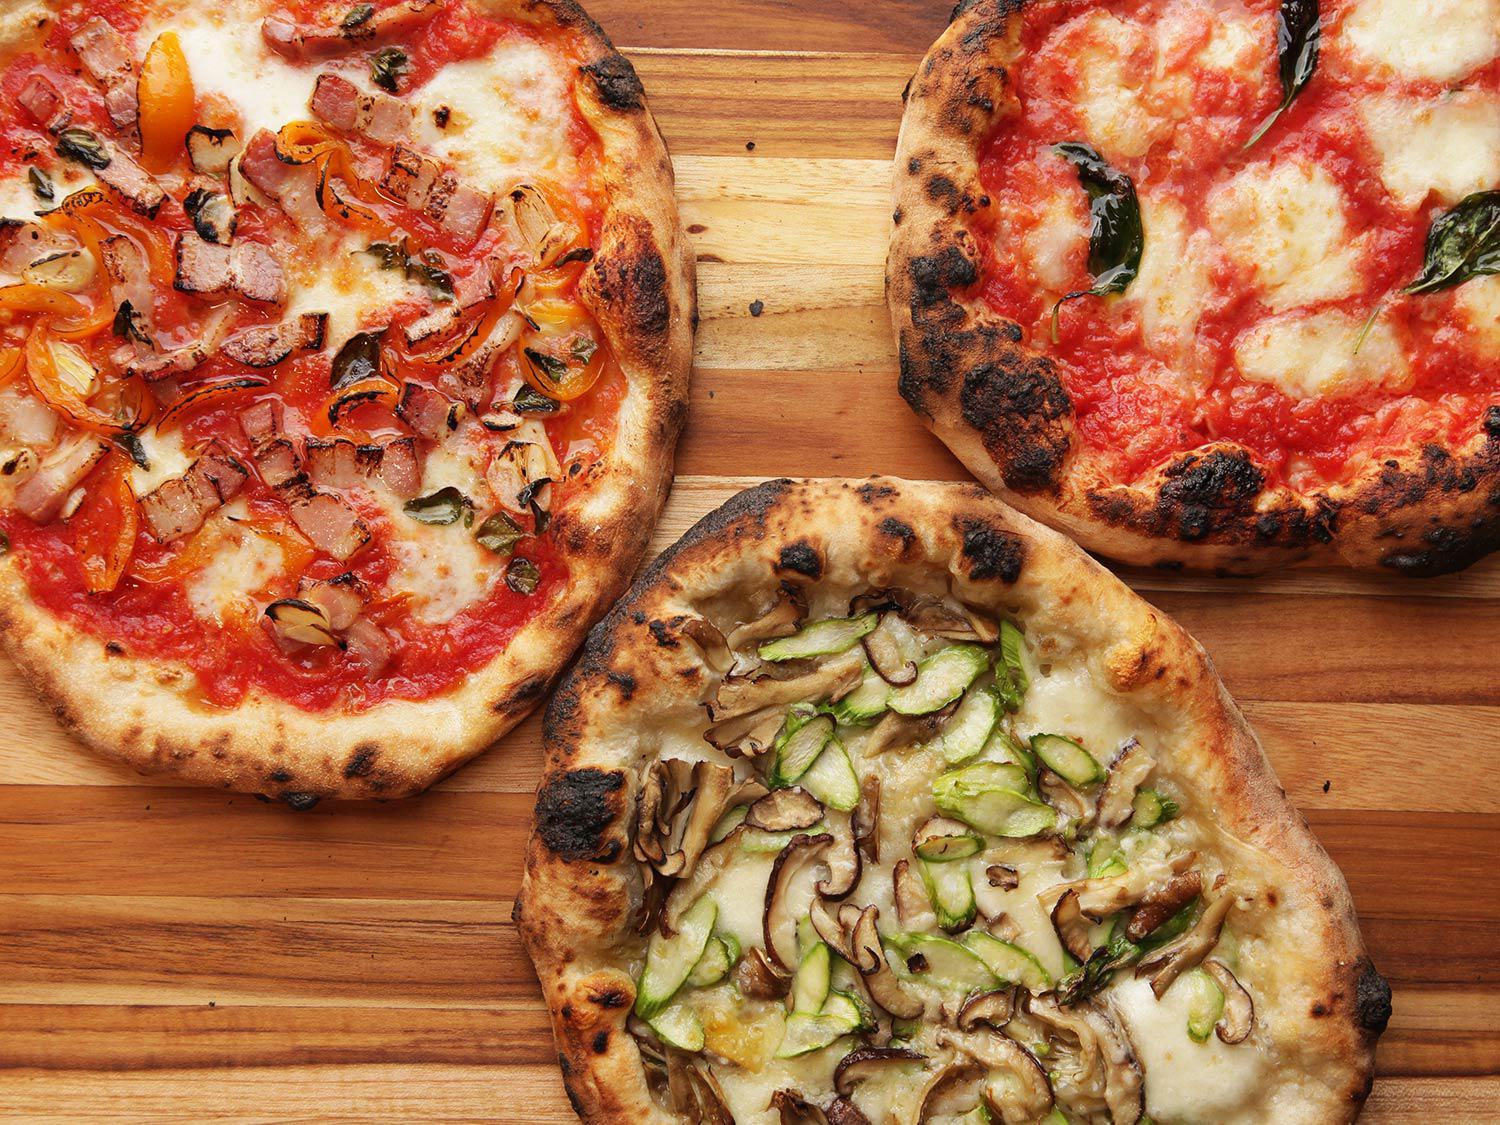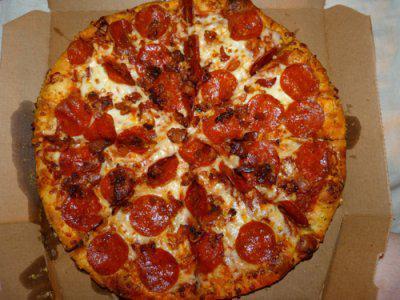The first image is the image on the left, the second image is the image on the right. For the images displayed, is the sentence "One slice of pizza is being separated from the rest." factually correct? Answer yes or no. No. The first image is the image on the left, the second image is the image on the right. For the images shown, is this caption "A whole pizza is on a pizza box in the right image." true? Answer yes or no. Yes. 